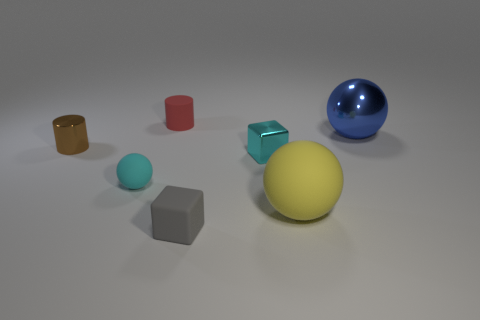Are there the same number of small gray cubes left of the red matte cylinder and matte cylinders that are on the left side of the brown object?
Your answer should be compact. Yes. There is a large blue metallic object that is in front of the small red matte thing; is its shape the same as the big yellow rubber thing?
Your answer should be very brief. Yes. How many brown things are either metallic blocks or rubber cubes?
Your response must be concise. 0. What is the material of the small red thing that is the same shape as the tiny brown shiny thing?
Offer a terse response. Rubber. The shiny object that is right of the big yellow object has what shape?
Give a very brief answer. Sphere. Are there any cyan spheres made of the same material as the gray thing?
Your answer should be very brief. Yes. Do the yellow matte sphere and the cyan metal block have the same size?
Provide a succinct answer. No. What number of cubes are small green things or tiny matte things?
Make the answer very short. 1. What material is the cube that is the same color as the small sphere?
Provide a short and direct response. Metal. What number of other tiny things are the same shape as the brown metallic object?
Provide a short and direct response. 1. 